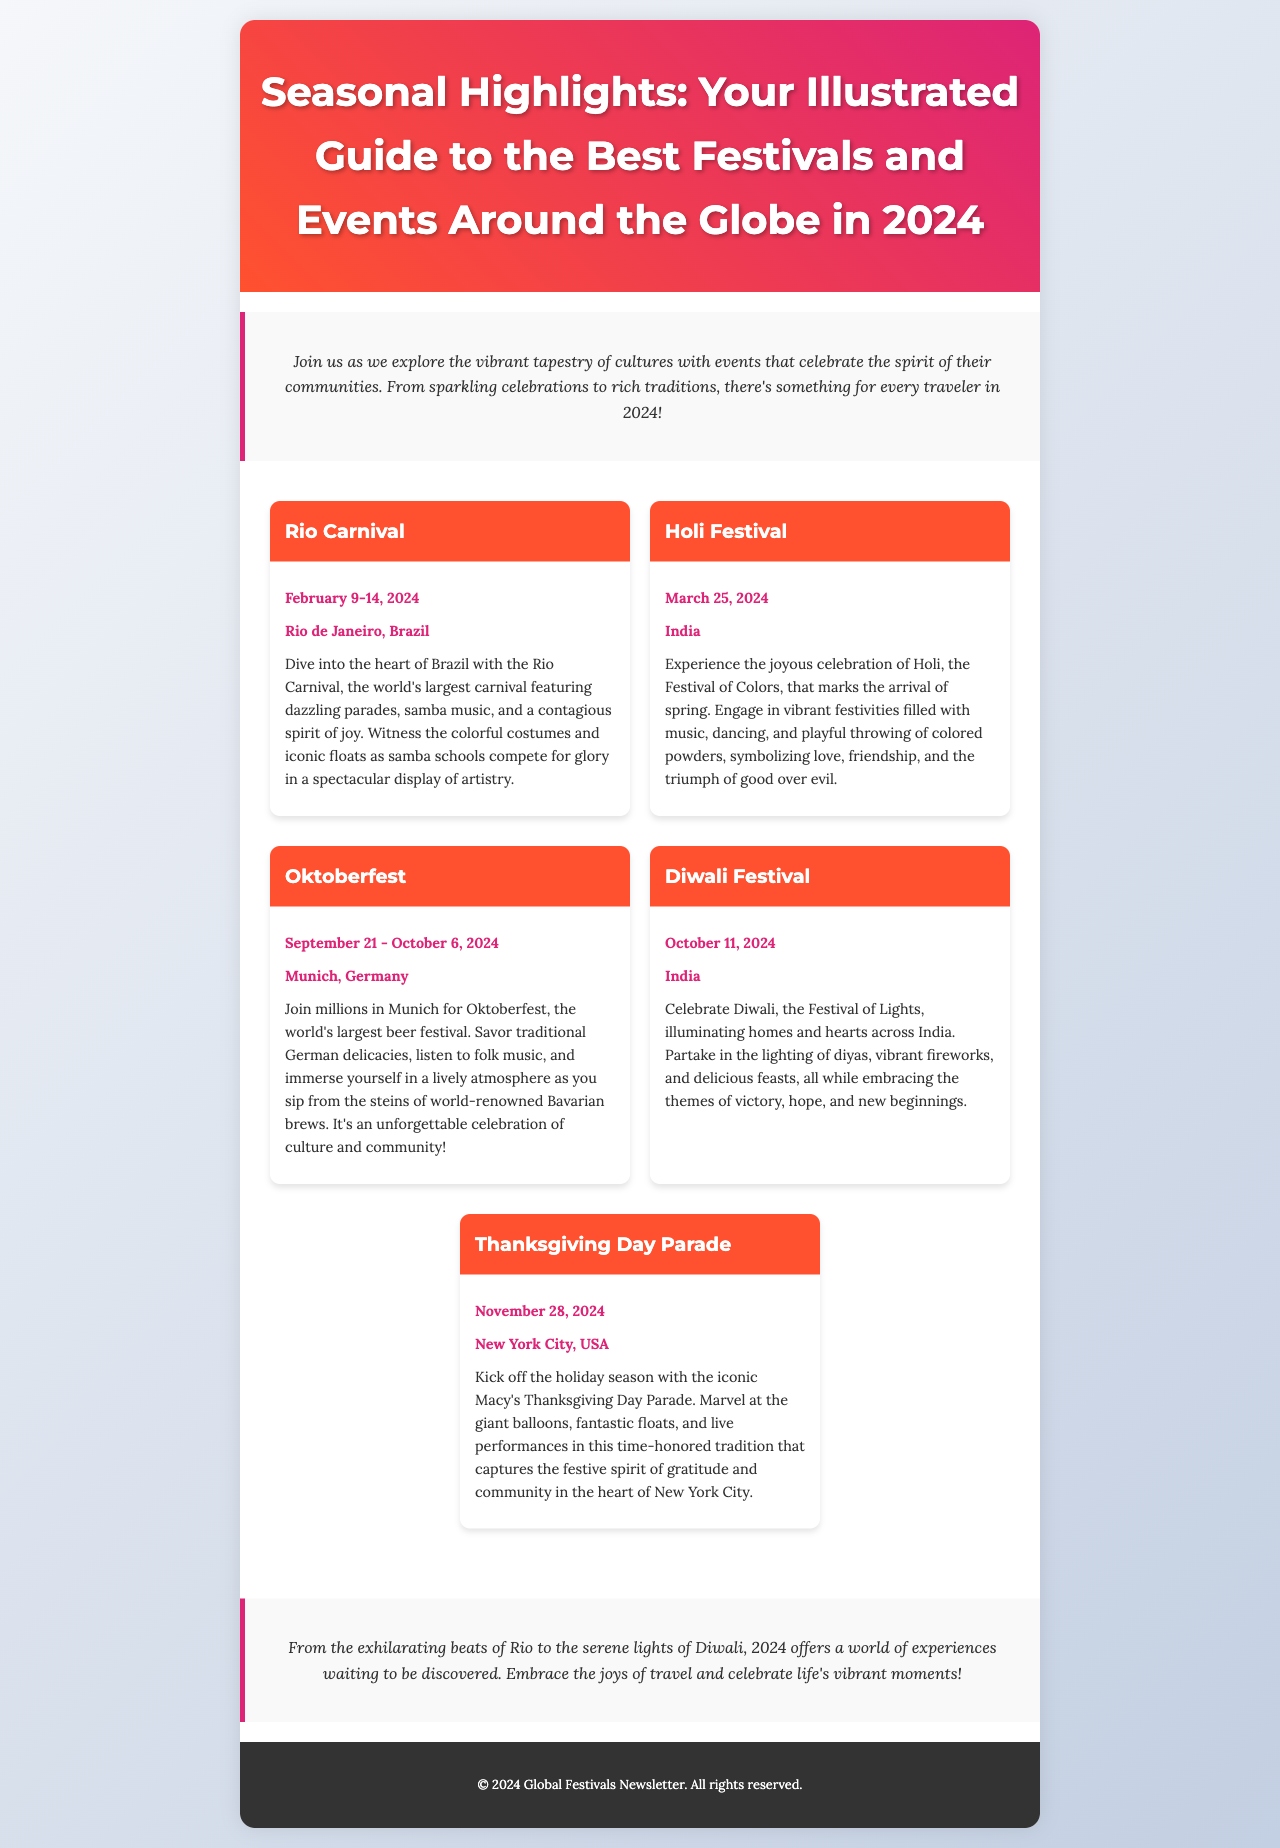What is the date range for the Rio Carnival? The date range for the Rio Carnival is stated in the document, which specifies February 9-14, 2024.
Answer: February 9-14, 2024 What is the location of the Oktoberfest? The location for the Oktoberfest is mentioned as Munich, Germany in the document.
Answer: Munich, Germany What special event occurs on March 25, 2024? The document provides details about events, noting that the Holi Festival takes place on March 25, 2024.
Answer: Holi Festival How many days does the Oktoberfest last? The duration of the Oktoberfest is indicated in the document as it runs from September 21 to October 6, 2024, totaling 16 days.
Answer: 16 days Which festival is celebrated as the Festival of Lights? The document identifies Diwali as the Festival of Lights.
Answer: Diwali What cultural theme is emphasized during the Holi Festival? The document mentions that Holi symbolizes love, friendship, and the triumph of good over evil, highlighting the cultural themes represented.
Answer: Love, friendship, triumph of good over evil What is the main attraction of the Macy's Thanksgiving Day Parade? In the document, the main attractions of the Macy's Thanksgiving Day Parade are described as giant balloons, fantastic floats, and live performances.
Answer: Giant balloons, fantastic floats, live performances Which event signifies the arrival of spring? The document states that the Holi Festival marks the arrival of spring.
Answer: Holi Festival How does the newsletter describe the experience of travel for 2024? The closing statement in the document expresses that 2024 offers a world of experiences waiting to be discovered.
Answer: A world of experiences waiting to be discovered 